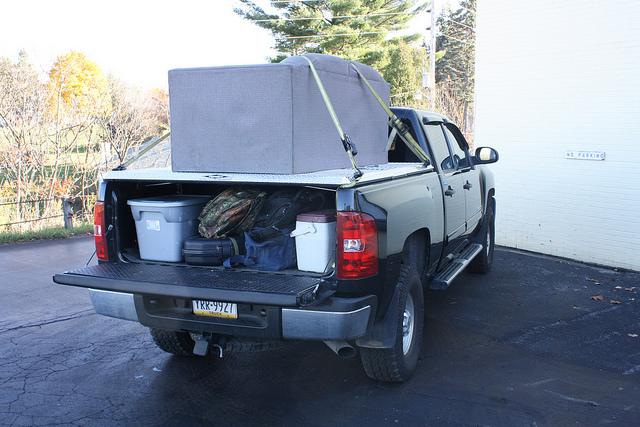Why is the couch on top of the truck?
Give a very brief answer. Moving. Is there a couch in the bed of the truck?
Give a very brief answer. Yes. Will the truck be able to move forward?
Write a very short answer. No. What pattern is shown on the book bag?
Keep it brief. Camo. 